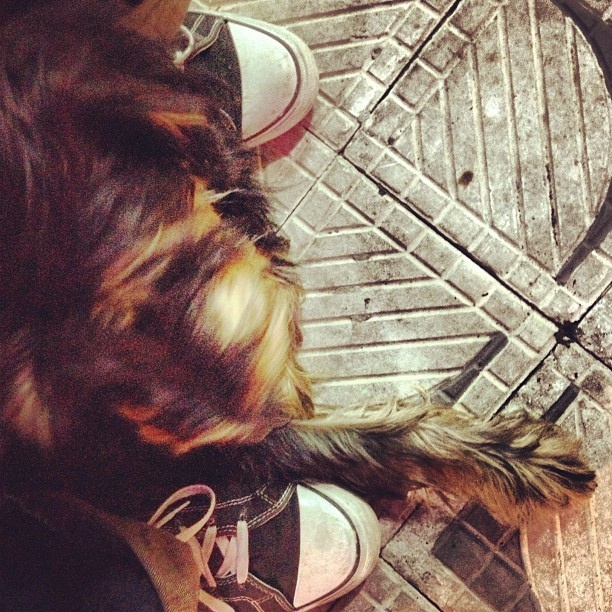Describe the objects in this image and their specific colors. I can see a dog in black, maroon, and brown tones in this image. 